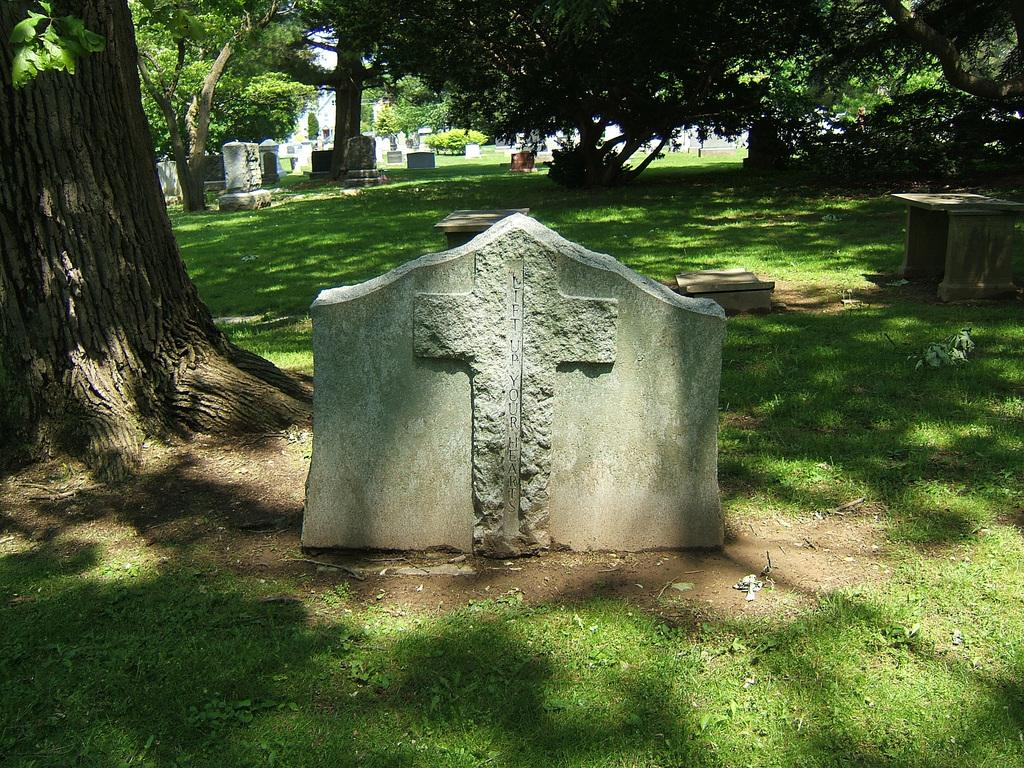What is marked on the stone in the image? There is a cross mark on a stone in the image. What is the ground surface like in the image? The ground is covered with grass. What can be seen in the background of the image? There is a graveyard and many trees in the background of the image. What type of power source is used to light up the cross mark on the stone in the image? There is no indication of any power source or lighting in the image; the cross mark is simply marked on the stone. 